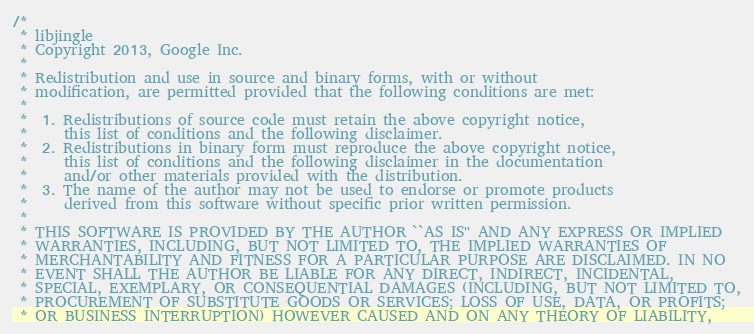<code> <loc_0><loc_0><loc_500><loc_500><_C_>/*
 * libjingle
 * Copyright 2013, Google Inc.
 *
 * Redistribution and use in source and binary forms, with or without
 * modification, are permitted provided that the following conditions are met:
 *
 *  1. Redistributions of source code must retain the above copyright notice,
 *     this list of conditions and the following disclaimer.
 *  2. Redistributions in binary form must reproduce the above copyright notice,
 *     this list of conditions and the following disclaimer in the documentation
 *     and/or other materials provided with the distribution.
 *  3. The name of the author may not be used to endorse or promote products
 *     derived from this software without specific prior written permission.
 *
 * THIS SOFTWARE IS PROVIDED BY THE AUTHOR ``AS IS'' AND ANY EXPRESS OR IMPLIED
 * WARRANTIES, INCLUDING, BUT NOT LIMITED TO, THE IMPLIED WARRANTIES OF
 * MERCHANTABILITY AND FITNESS FOR A PARTICULAR PURPOSE ARE DISCLAIMED. IN NO
 * EVENT SHALL THE AUTHOR BE LIABLE FOR ANY DIRECT, INDIRECT, INCIDENTAL,
 * SPECIAL, EXEMPLARY, OR CONSEQUENTIAL DAMAGES (INCLUDING, BUT NOT LIMITED TO,
 * PROCUREMENT OF SUBSTITUTE GOODS OR SERVICES; LOSS OF USE, DATA, OR PROFITS;
 * OR BUSINESS INTERRUPTION) HOWEVER CAUSED AND ON ANY THEORY OF LIABILITY,</code> 